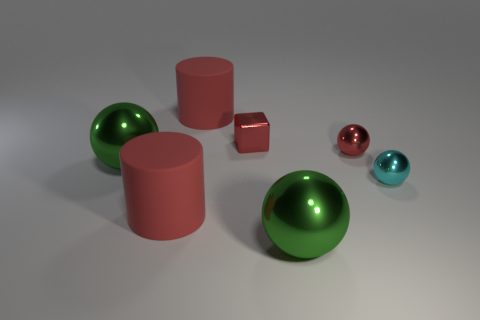Add 3 red spheres. How many objects exist? 10 Subtract all cylinders. How many objects are left? 5 Subtract 0 gray balls. How many objects are left? 7 Subtract all purple shiny blocks. Subtract all big red cylinders. How many objects are left? 5 Add 2 green metallic objects. How many green metallic objects are left? 4 Add 7 large green metallic balls. How many large green metallic balls exist? 9 